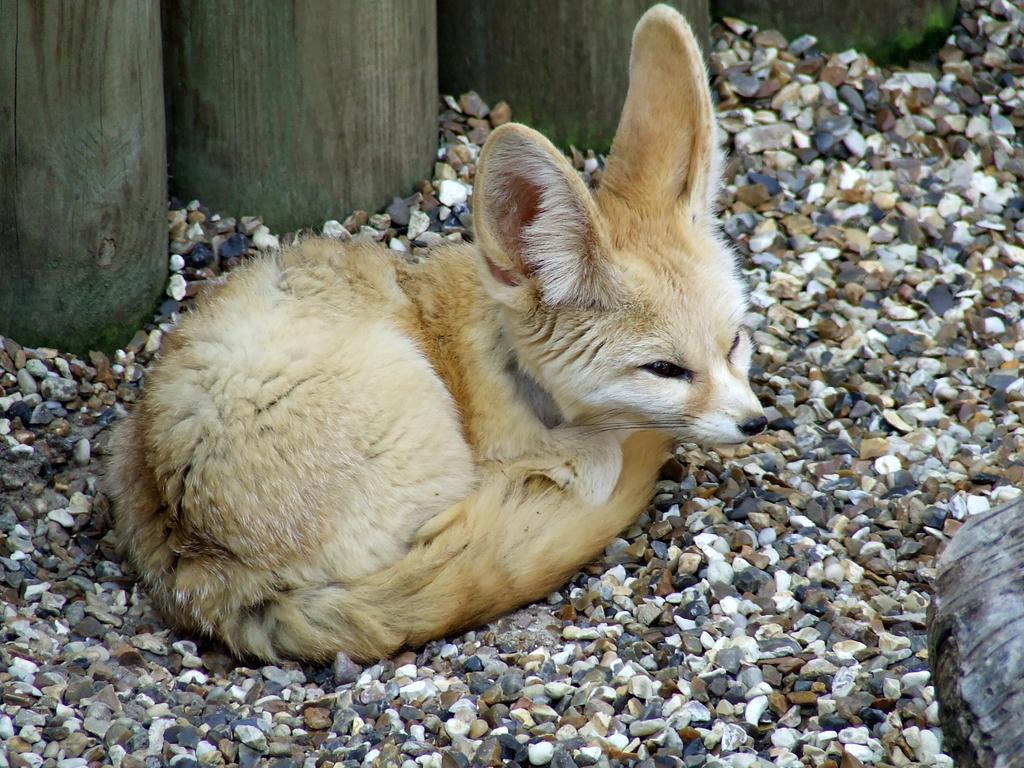What type of creature can be seen in the image? There is an animal in the image. What is the animal sitting on? The animal is sitting on stones. What can be seen in the background of the image? There is a wooden trunk in the background of the image. What type of stem can be seen growing from the animal's back in the image? There is no stem growing from the animal's back in the image. What color is the gold that the animal is holding in the image? There is no gold present in the image. 